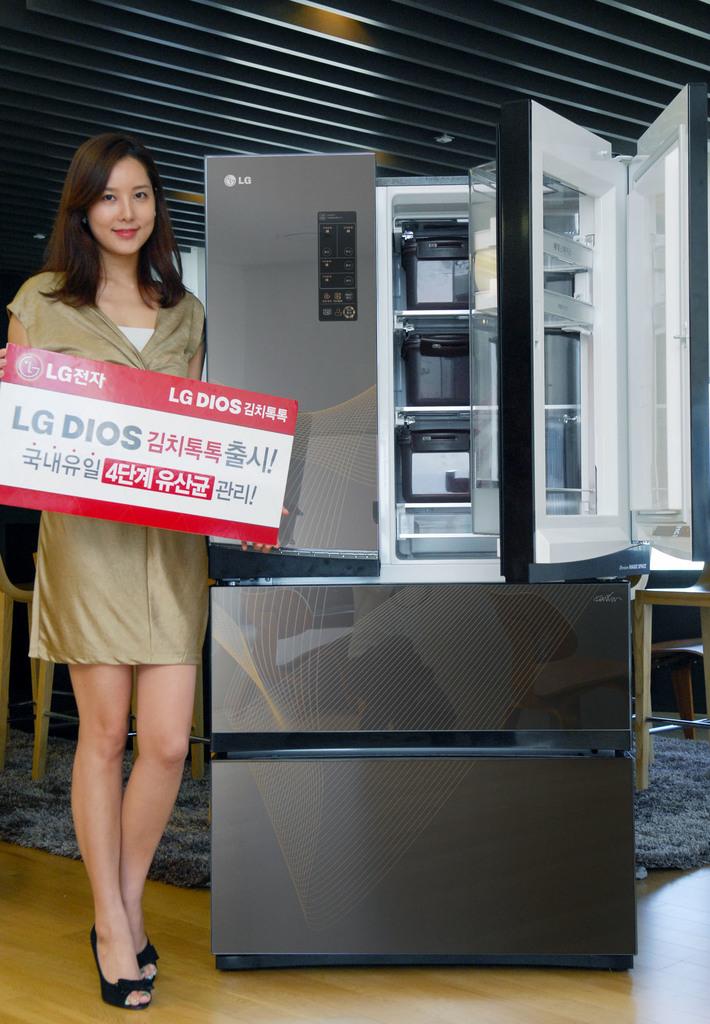What company is advertised?
Your answer should be compact. Lg. 